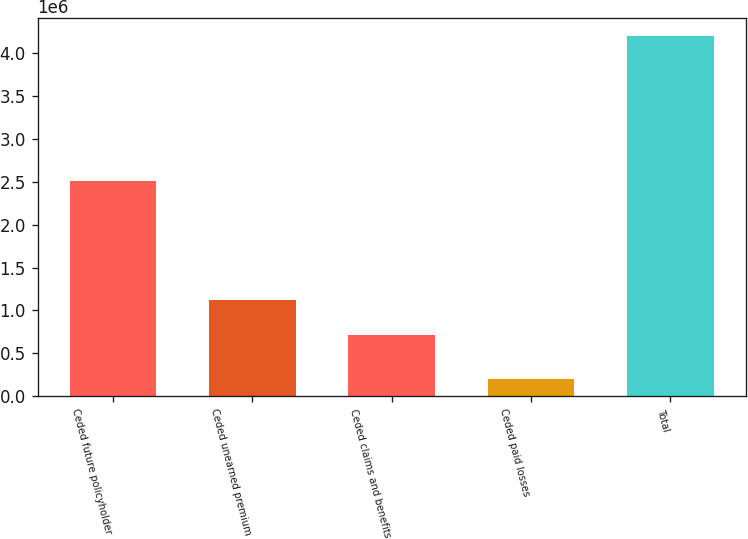Convert chart to OTSL. <chart><loc_0><loc_0><loc_500><loc_500><bar_chart><fcel>Ceded future policyholder<fcel>Ceded unearned premium<fcel>Ceded claims and benefits<fcel>Ceded paid losses<fcel>Total<nl><fcel>2.50745e+06<fcel>1.11602e+06<fcel>716871<fcel>205365<fcel>4.19681e+06<nl></chart> 